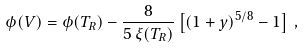<formula> <loc_0><loc_0><loc_500><loc_500>\phi ( V ) = \phi ( T _ { R } ) - \frac { 8 } { 5 \, \xi ( T _ { R } ) } \left [ ( 1 + y ) ^ { 5 / 8 } - 1 \right ] \, ,</formula> 